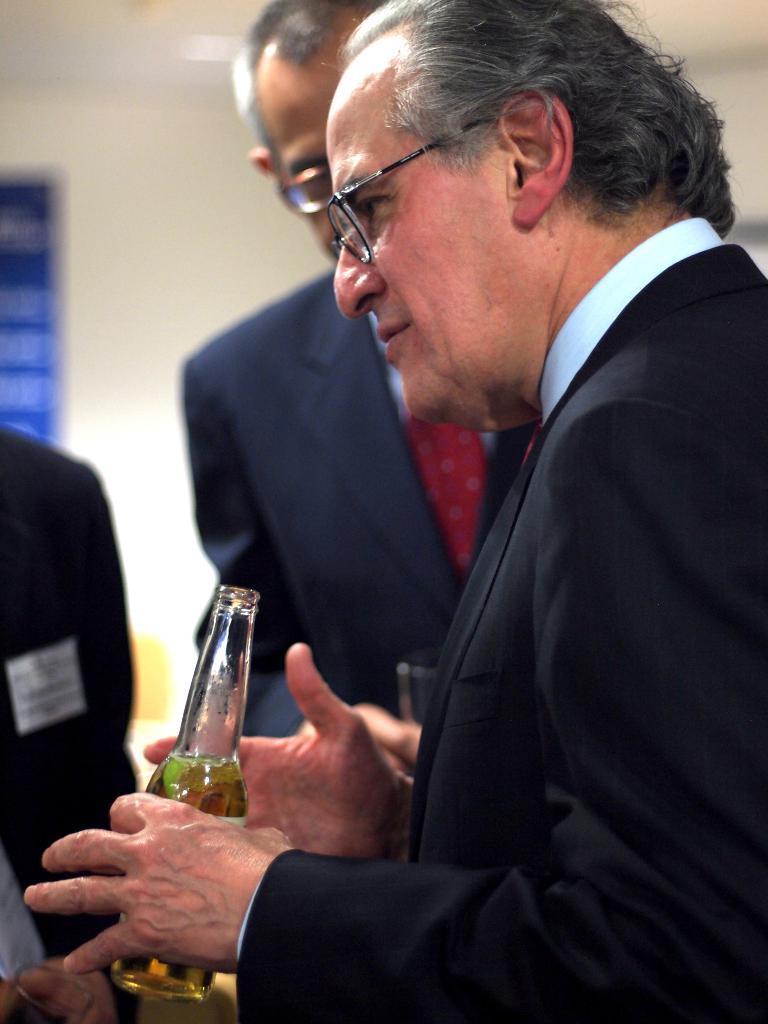How would you summarize this image in a sentence or two? This picture shows a man holding a beer bottle in his hand and speaking with other people 